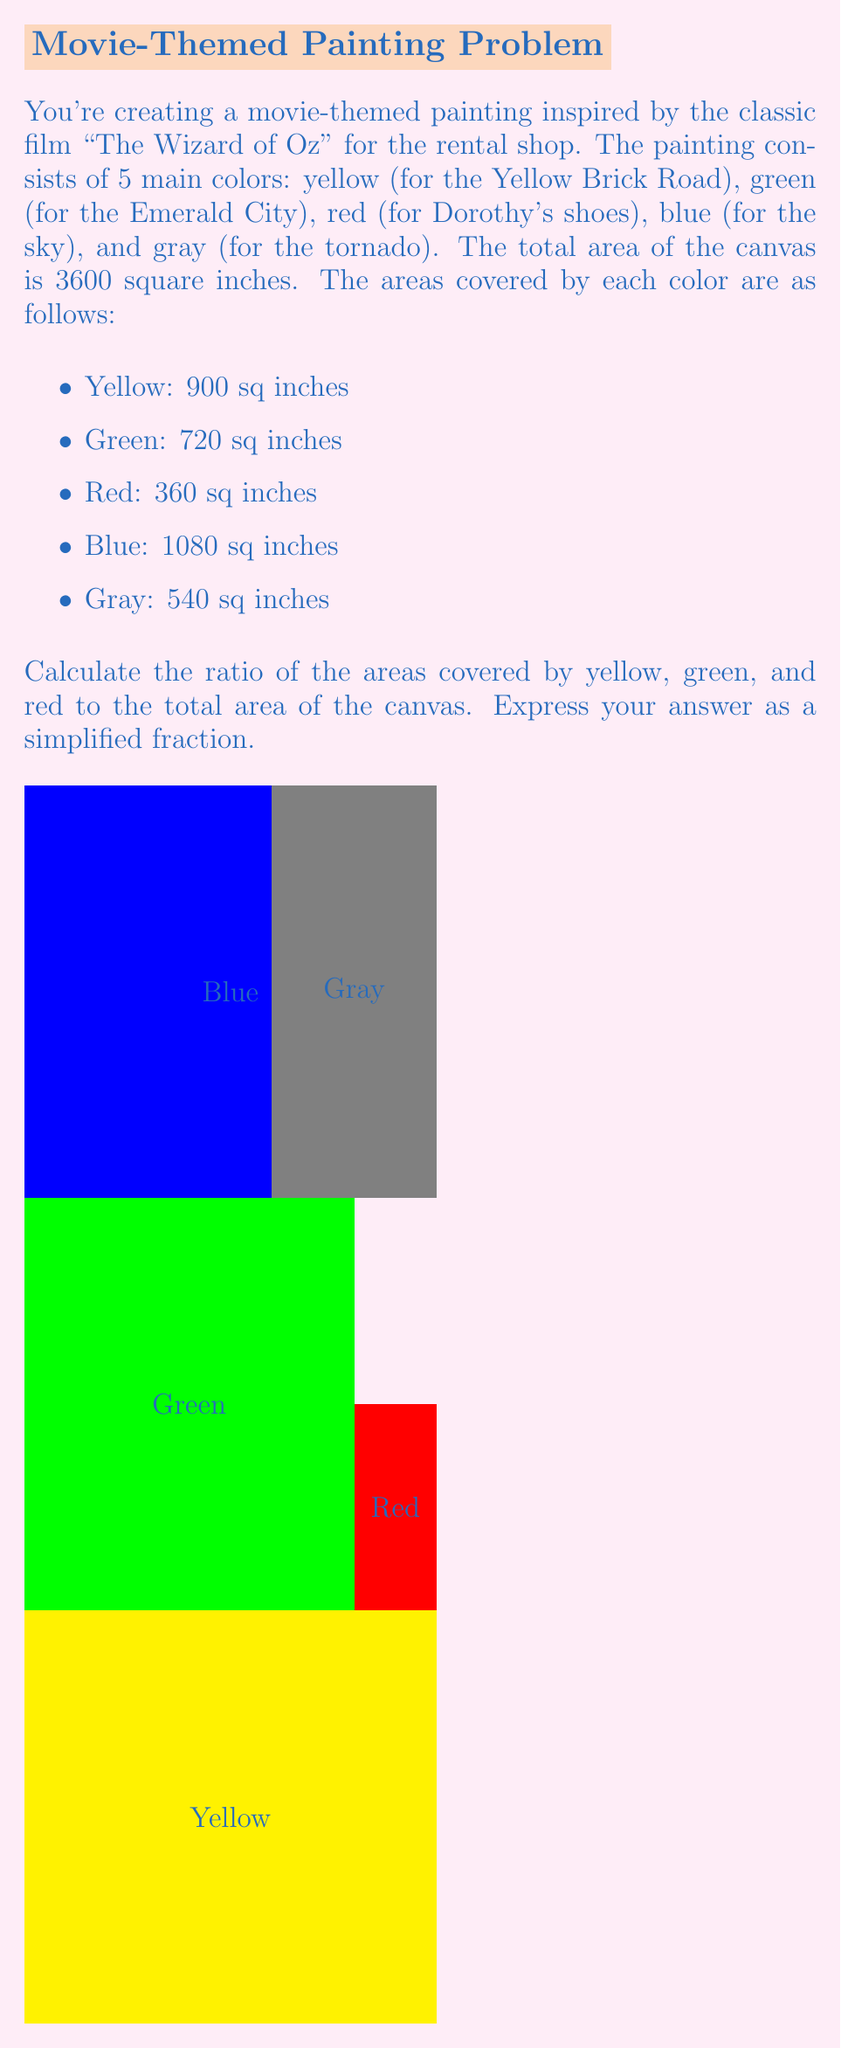Solve this math problem. Let's approach this step-by-step:

1) First, we need to find the total area covered by yellow, green, and red:
   Yellow: 900 sq inches
   Green: 720 sq inches
   Red: 360 sq inches
   
   Total = 900 + 720 + 360 = 1980 sq inches

2) Now, we need to express this as a ratio to the total canvas area:
   Ratio = (Area of yellow + green + red) : (Total canvas area)
   Ratio = 1980 : 3600

3) To simplify this ratio, we need to find the greatest common divisor (GCD) of 1980 and 3600:
   
   Factors of 1980: 1, 2, 3, 4, 5, 6, 9, 10, 11, 12, 15, 18, 20, 22, 30, 33, 36, 44, 45, 55, 60, 66, 90, 99, 110, 132, 165, 180, 198, 220, 330, 396, 495, 660, 990, 1980
   
   Factors of 3600: 1, 2, 3, 4, 5, 6, 8, 9, 10, 12, 15, 16, 18, 20, 24, 25, 30, 36, 40, 45, 50, 60, 72, 75, 80, 90, 100, 120, 150, 180, 200, 225, 300, 360, 400, 450, 600, 900, 1200, 1800, 3600

   The greatest common divisor is 180.

4) Divide both numbers by 180:
   1980 ÷ 180 = 11
   3600 ÷ 180 = 20

Therefore, the simplified ratio is 11:20.
Answer: $\frac{11}{20}$ 